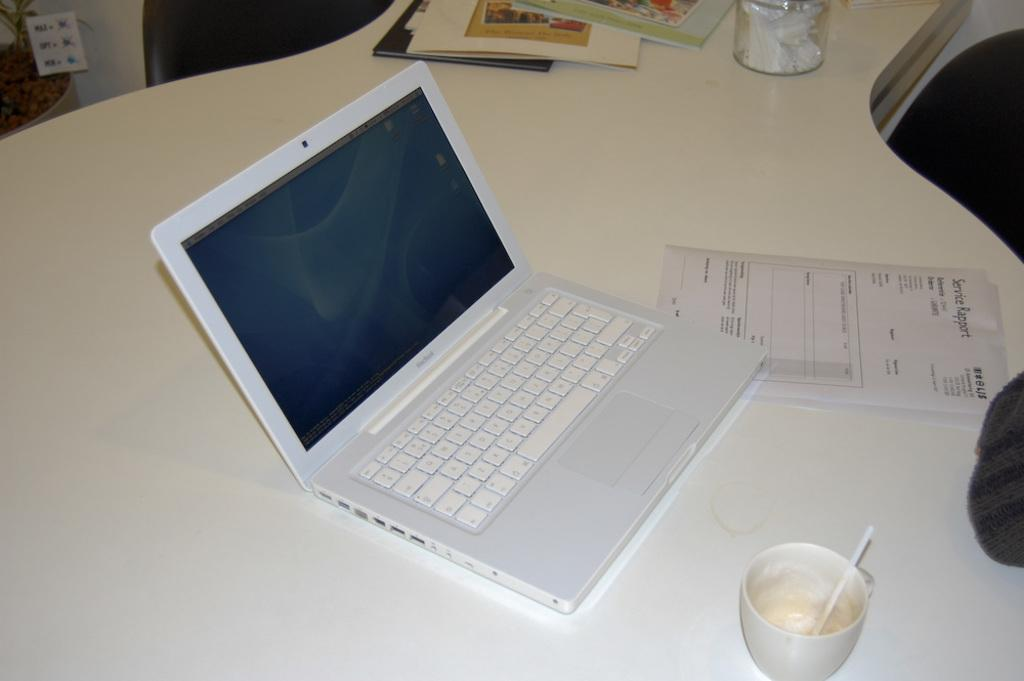What piece of furniture is present in the image? There is a table in the image. What electronic device is on the table? There is a laptop on the table. What type of writing material is on the table? There is a paper on the table. What beverage container is on the table? There is a cup on the table. What type of reading material is on the table? There are books on the table. What type of coach can be seen in the image? There is no coach present in the image. What type of birds are flying around the table in the image? There are no birds present in the image. 